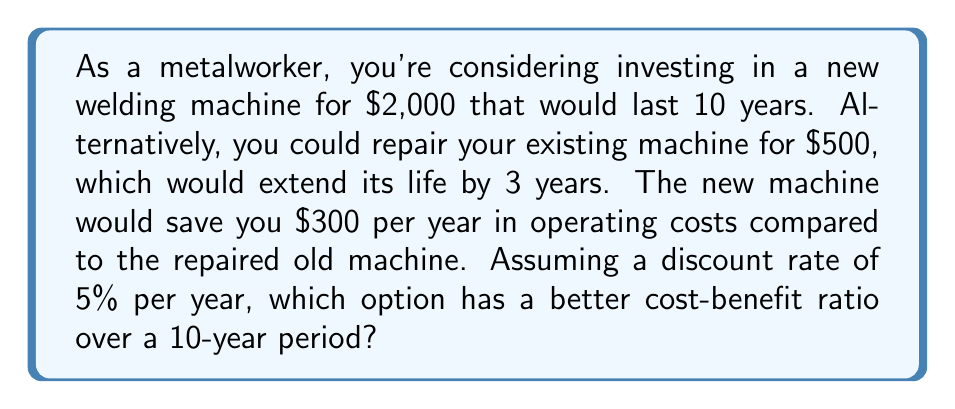Can you solve this math problem? To solve this problem, we need to calculate the Net Present Value (NPV) of both options over a 10-year period and compare their cost-benefit ratios.

Option 1: New Machine
Cost: $2,000 upfront
Benefit: $300 savings per year for 10 years

NPV of costs: $2,000 (since it's an immediate expense)
NPV of benefits:
$$NPV_{benefits} = \sum_{t=1}^{10} \frac{300}{(1 + 0.05)^t}$$

Using the present value of an annuity formula:
$$NPV_{benefits} = 300 \cdot \frac{1 - (1 + 0.05)^{-10}}{0.05} \approx 2,316.26$$

Cost-Benefit Ratio for New Machine:
$$\frac{Benefits}{Costs} = \frac{2,316.26}{2,000} \approx 1.16$$

Option 2: Repair Old Machine
For this option, we need to consider two cycles of repair over the 10-year period.

Cycle 1: Years 1-3
Cost: $500 upfront
No additional benefits (as it's the baseline)

Cycle 2: Years 4-6
Cost: $500 at the start of year 4
No additional benefits

Cycle 3: Years 7-9
Cost: $500 at the start of year 7
No additional benefits

Year 10: We assume no repair is needed for just one year

NPV of costs:
$$NPV_{costs} = 500 + \frac{500}{(1 + 0.05)^3} + \frac{500}{(1 + 0.05)^6} \approx 1,299.40$$

NPV of benefits: $0 (as this is the baseline scenario)

Cost-Benefit Ratio for Repairing Old Machine:
$$\frac{Benefits}{Costs} = \frac{0}{1,299.40} = 0$$
Answer: The new machine has a better cost-benefit ratio of 1.16 compared to 0 for repairing the old machine. Therefore, investing in the new welding machine is the better option over the 10-year period. 